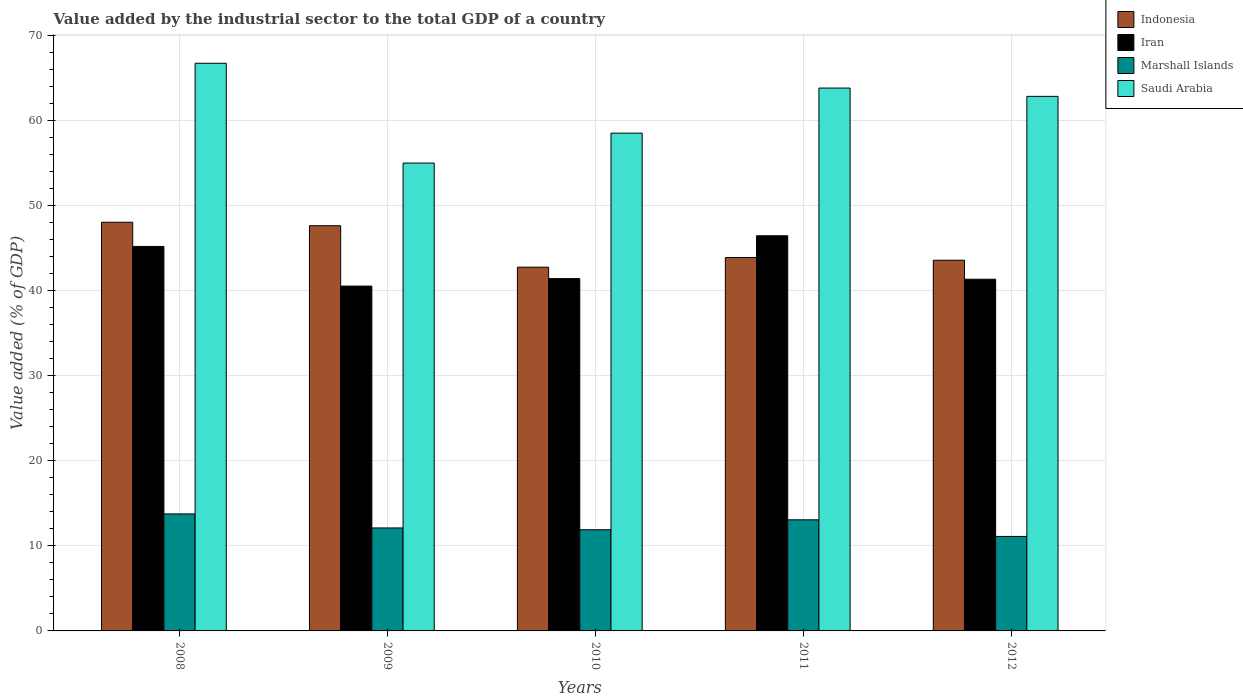How many different coloured bars are there?
Provide a succinct answer. 4. How many groups of bars are there?
Offer a terse response. 5. Are the number of bars per tick equal to the number of legend labels?
Provide a short and direct response. Yes. Are the number of bars on each tick of the X-axis equal?
Ensure brevity in your answer.  Yes. How many bars are there on the 3rd tick from the right?
Offer a terse response. 4. In how many cases, is the number of bars for a given year not equal to the number of legend labels?
Make the answer very short. 0. What is the value added by the industrial sector to the total GDP in Indonesia in 2010?
Keep it short and to the point. 42.78. Across all years, what is the maximum value added by the industrial sector to the total GDP in Indonesia?
Ensure brevity in your answer.  48.06. Across all years, what is the minimum value added by the industrial sector to the total GDP in Indonesia?
Ensure brevity in your answer.  42.78. In which year was the value added by the industrial sector to the total GDP in Iran maximum?
Provide a succinct answer. 2011. In which year was the value added by the industrial sector to the total GDP in Iran minimum?
Give a very brief answer. 2009. What is the total value added by the industrial sector to the total GDP in Marshall Islands in the graph?
Offer a very short reply. 61.95. What is the difference between the value added by the industrial sector to the total GDP in Iran in 2009 and that in 2011?
Give a very brief answer. -5.92. What is the difference between the value added by the industrial sector to the total GDP in Indonesia in 2009 and the value added by the industrial sector to the total GDP in Iran in 2012?
Give a very brief answer. 6.29. What is the average value added by the industrial sector to the total GDP in Iran per year?
Give a very brief answer. 43.01. In the year 2010, what is the difference between the value added by the industrial sector to the total GDP in Saudi Arabia and value added by the industrial sector to the total GDP in Marshall Islands?
Give a very brief answer. 46.64. In how many years, is the value added by the industrial sector to the total GDP in Indonesia greater than 48 %?
Offer a terse response. 1. What is the ratio of the value added by the industrial sector to the total GDP in Iran in 2008 to that in 2012?
Keep it short and to the point. 1.09. Is the difference between the value added by the industrial sector to the total GDP in Saudi Arabia in 2011 and 2012 greater than the difference between the value added by the industrial sector to the total GDP in Marshall Islands in 2011 and 2012?
Give a very brief answer. No. What is the difference between the highest and the second highest value added by the industrial sector to the total GDP in Saudi Arabia?
Give a very brief answer. 2.92. What is the difference between the highest and the lowest value added by the industrial sector to the total GDP in Saudi Arabia?
Your response must be concise. 11.74. Is it the case that in every year, the sum of the value added by the industrial sector to the total GDP in Saudi Arabia and value added by the industrial sector to the total GDP in Iran is greater than the sum of value added by the industrial sector to the total GDP in Indonesia and value added by the industrial sector to the total GDP in Marshall Islands?
Keep it short and to the point. Yes. What does the 2nd bar from the right in 2008 represents?
Offer a terse response. Marshall Islands. Is it the case that in every year, the sum of the value added by the industrial sector to the total GDP in Saudi Arabia and value added by the industrial sector to the total GDP in Indonesia is greater than the value added by the industrial sector to the total GDP in Marshall Islands?
Provide a succinct answer. Yes. How many bars are there?
Provide a short and direct response. 20. How many years are there in the graph?
Offer a very short reply. 5. Are the values on the major ticks of Y-axis written in scientific E-notation?
Make the answer very short. No. Does the graph contain grids?
Provide a short and direct response. Yes. How many legend labels are there?
Ensure brevity in your answer.  4. What is the title of the graph?
Make the answer very short. Value added by the industrial sector to the total GDP of a country. Does "Swaziland" appear as one of the legend labels in the graph?
Make the answer very short. No. What is the label or title of the X-axis?
Keep it short and to the point. Years. What is the label or title of the Y-axis?
Your answer should be very brief. Value added (% of GDP). What is the Value added (% of GDP) of Indonesia in 2008?
Your answer should be compact. 48.06. What is the Value added (% of GDP) of Iran in 2008?
Provide a succinct answer. 45.21. What is the Value added (% of GDP) in Marshall Islands in 2008?
Offer a very short reply. 13.76. What is the Value added (% of GDP) of Saudi Arabia in 2008?
Offer a very short reply. 66.76. What is the Value added (% of GDP) of Indonesia in 2009?
Make the answer very short. 47.65. What is the Value added (% of GDP) in Iran in 2009?
Ensure brevity in your answer.  40.55. What is the Value added (% of GDP) of Marshall Islands in 2009?
Your response must be concise. 12.11. What is the Value added (% of GDP) in Saudi Arabia in 2009?
Your answer should be compact. 55.02. What is the Value added (% of GDP) in Indonesia in 2010?
Offer a terse response. 42.78. What is the Value added (% of GDP) of Iran in 2010?
Give a very brief answer. 41.43. What is the Value added (% of GDP) in Marshall Islands in 2010?
Give a very brief answer. 11.9. What is the Value added (% of GDP) of Saudi Arabia in 2010?
Make the answer very short. 58.54. What is the Value added (% of GDP) of Indonesia in 2011?
Offer a very short reply. 43.91. What is the Value added (% of GDP) in Iran in 2011?
Offer a very short reply. 46.47. What is the Value added (% of GDP) in Marshall Islands in 2011?
Give a very brief answer. 13.07. What is the Value added (% of GDP) of Saudi Arabia in 2011?
Ensure brevity in your answer.  63.84. What is the Value added (% of GDP) in Indonesia in 2012?
Offer a terse response. 43.59. What is the Value added (% of GDP) in Iran in 2012?
Keep it short and to the point. 41.36. What is the Value added (% of GDP) in Marshall Islands in 2012?
Offer a very short reply. 11.11. What is the Value added (% of GDP) of Saudi Arabia in 2012?
Offer a terse response. 62.86. Across all years, what is the maximum Value added (% of GDP) in Indonesia?
Make the answer very short. 48.06. Across all years, what is the maximum Value added (% of GDP) of Iran?
Offer a very short reply. 46.47. Across all years, what is the maximum Value added (% of GDP) in Marshall Islands?
Provide a short and direct response. 13.76. Across all years, what is the maximum Value added (% of GDP) of Saudi Arabia?
Provide a succinct answer. 66.76. Across all years, what is the minimum Value added (% of GDP) in Indonesia?
Offer a very short reply. 42.78. Across all years, what is the minimum Value added (% of GDP) in Iran?
Provide a short and direct response. 40.55. Across all years, what is the minimum Value added (% of GDP) of Marshall Islands?
Your answer should be very brief. 11.11. Across all years, what is the minimum Value added (% of GDP) in Saudi Arabia?
Give a very brief answer. 55.02. What is the total Value added (% of GDP) in Indonesia in the graph?
Give a very brief answer. 226. What is the total Value added (% of GDP) in Iran in the graph?
Ensure brevity in your answer.  215.03. What is the total Value added (% of GDP) of Marshall Islands in the graph?
Give a very brief answer. 61.95. What is the total Value added (% of GDP) of Saudi Arabia in the graph?
Make the answer very short. 307.02. What is the difference between the Value added (% of GDP) of Indonesia in 2008 and that in 2009?
Give a very brief answer. 0.41. What is the difference between the Value added (% of GDP) of Iran in 2008 and that in 2009?
Offer a terse response. 4.66. What is the difference between the Value added (% of GDP) of Marshall Islands in 2008 and that in 2009?
Your response must be concise. 1.65. What is the difference between the Value added (% of GDP) of Saudi Arabia in 2008 and that in 2009?
Your answer should be very brief. 11.74. What is the difference between the Value added (% of GDP) in Indonesia in 2008 and that in 2010?
Ensure brevity in your answer.  5.28. What is the difference between the Value added (% of GDP) of Iran in 2008 and that in 2010?
Provide a short and direct response. 3.78. What is the difference between the Value added (% of GDP) in Marshall Islands in 2008 and that in 2010?
Offer a terse response. 1.86. What is the difference between the Value added (% of GDP) of Saudi Arabia in 2008 and that in 2010?
Your response must be concise. 8.22. What is the difference between the Value added (% of GDP) of Indonesia in 2008 and that in 2011?
Your answer should be very brief. 4.15. What is the difference between the Value added (% of GDP) in Iran in 2008 and that in 2011?
Offer a terse response. -1.26. What is the difference between the Value added (% of GDP) of Marshall Islands in 2008 and that in 2011?
Your response must be concise. 0.69. What is the difference between the Value added (% of GDP) of Saudi Arabia in 2008 and that in 2011?
Give a very brief answer. 2.92. What is the difference between the Value added (% of GDP) of Indonesia in 2008 and that in 2012?
Offer a very short reply. 4.47. What is the difference between the Value added (% of GDP) of Iran in 2008 and that in 2012?
Make the answer very short. 3.85. What is the difference between the Value added (% of GDP) in Marshall Islands in 2008 and that in 2012?
Your answer should be very brief. 2.65. What is the difference between the Value added (% of GDP) of Saudi Arabia in 2008 and that in 2012?
Ensure brevity in your answer.  3.89. What is the difference between the Value added (% of GDP) of Indonesia in 2009 and that in 2010?
Ensure brevity in your answer.  4.88. What is the difference between the Value added (% of GDP) of Iran in 2009 and that in 2010?
Give a very brief answer. -0.88. What is the difference between the Value added (% of GDP) of Marshall Islands in 2009 and that in 2010?
Provide a short and direct response. 0.21. What is the difference between the Value added (% of GDP) of Saudi Arabia in 2009 and that in 2010?
Provide a short and direct response. -3.52. What is the difference between the Value added (% of GDP) of Indonesia in 2009 and that in 2011?
Your answer should be very brief. 3.74. What is the difference between the Value added (% of GDP) in Iran in 2009 and that in 2011?
Ensure brevity in your answer.  -5.92. What is the difference between the Value added (% of GDP) in Marshall Islands in 2009 and that in 2011?
Offer a very short reply. -0.96. What is the difference between the Value added (% of GDP) in Saudi Arabia in 2009 and that in 2011?
Give a very brief answer. -8.82. What is the difference between the Value added (% of GDP) of Indonesia in 2009 and that in 2012?
Offer a terse response. 4.06. What is the difference between the Value added (% of GDP) in Iran in 2009 and that in 2012?
Offer a very short reply. -0.81. What is the difference between the Value added (% of GDP) in Saudi Arabia in 2009 and that in 2012?
Your response must be concise. -7.84. What is the difference between the Value added (% of GDP) in Indonesia in 2010 and that in 2011?
Keep it short and to the point. -1.14. What is the difference between the Value added (% of GDP) in Iran in 2010 and that in 2011?
Make the answer very short. -5.04. What is the difference between the Value added (% of GDP) in Marshall Islands in 2010 and that in 2011?
Provide a short and direct response. -1.17. What is the difference between the Value added (% of GDP) in Saudi Arabia in 2010 and that in 2011?
Provide a succinct answer. -5.3. What is the difference between the Value added (% of GDP) in Indonesia in 2010 and that in 2012?
Make the answer very short. -0.82. What is the difference between the Value added (% of GDP) in Iran in 2010 and that in 2012?
Give a very brief answer. 0.07. What is the difference between the Value added (% of GDP) of Marshall Islands in 2010 and that in 2012?
Make the answer very short. 0.79. What is the difference between the Value added (% of GDP) in Saudi Arabia in 2010 and that in 2012?
Your answer should be very brief. -4.32. What is the difference between the Value added (% of GDP) in Indonesia in 2011 and that in 2012?
Provide a short and direct response. 0.32. What is the difference between the Value added (% of GDP) in Iran in 2011 and that in 2012?
Give a very brief answer. 5.11. What is the difference between the Value added (% of GDP) of Marshall Islands in 2011 and that in 2012?
Give a very brief answer. 1.95. What is the difference between the Value added (% of GDP) of Saudi Arabia in 2011 and that in 2012?
Provide a short and direct response. 0.98. What is the difference between the Value added (% of GDP) in Indonesia in 2008 and the Value added (% of GDP) in Iran in 2009?
Keep it short and to the point. 7.51. What is the difference between the Value added (% of GDP) in Indonesia in 2008 and the Value added (% of GDP) in Marshall Islands in 2009?
Give a very brief answer. 35.95. What is the difference between the Value added (% of GDP) of Indonesia in 2008 and the Value added (% of GDP) of Saudi Arabia in 2009?
Offer a terse response. -6.96. What is the difference between the Value added (% of GDP) in Iran in 2008 and the Value added (% of GDP) in Marshall Islands in 2009?
Your answer should be very brief. 33.1. What is the difference between the Value added (% of GDP) of Iran in 2008 and the Value added (% of GDP) of Saudi Arabia in 2009?
Provide a succinct answer. -9.81. What is the difference between the Value added (% of GDP) in Marshall Islands in 2008 and the Value added (% of GDP) in Saudi Arabia in 2009?
Make the answer very short. -41.26. What is the difference between the Value added (% of GDP) in Indonesia in 2008 and the Value added (% of GDP) in Iran in 2010?
Make the answer very short. 6.63. What is the difference between the Value added (% of GDP) in Indonesia in 2008 and the Value added (% of GDP) in Marshall Islands in 2010?
Offer a very short reply. 36.16. What is the difference between the Value added (% of GDP) of Indonesia in 2008 and the Value added (% of GDP) of Saudi Arabia in 2010?
Ensure brevity in your answer.  -10.48. What is the difference between the Value added (% of GDP) of Iran in 2008 and the Value added (% of GDP) of Marshall Islands in 2010?
Keep it short and to the point. 33.32. What is the difference between the Value added (% of GDP) in Iran in 2008 and the Value added (% of GDP) in Saudi Arabia in 2010?
Provide a short and direct response. -13.32. What is the difference between the Value added (% of GDP) in Marshall Islands in 2008 and the Value added (% of GDP) in Saudi Arabia in 2010?
Give a very brief answer. -44.78. What is the difference between the Value added (% of GDP) of Indonesia in 2008 and the Value added (% of GDP) of Iran in 2011?
Your answer should be compact. 1.59. What is the difference between the Value added (% of GDP) in Indonesia in 2008 and the Value added (% of GDP) in Marshall Islands in 2011?
Keep it short and to the point. 34.99. What is the difference between the Value added (% of GDP) of Indonesia in 2008 and the Value added (% of GDP) of Saudi Arabia in 2011?
Give a very brief answer. -15.78. What is the difference between the Value added (% of GDP) in Iran in 2008 and the Value added (% of GDP) in Marshall Islands in 2011?
Give a very brief answer. 32.15. What is the difference between the Value added (% of GDP) of Iran in 2008 and the Value added (% of GDP) of Saudi Arabia in 2011?
Ensure brevity in your answer.  -18.63. What is the difference between the Value added (% of GDP) of Marshall Islands in 2008 and the Value added (% of GDP) of Saudi Arabia in 2011?
Make the answer very short. -50.08. What is the difference between the Value added (% of GDP) of Indonesia in 2008 and the Value added (% of GDP) of Iran in 2012?
Make the answer very short. 6.7. What is the difference between the Value added (% of GDP) in Indonesia in 2008 and the Value added (% of GDP) in Marshall Islands in 2012?
Provide a succinct answer. 36.95. What is the difference between the Value added (% of GDP) in Indonesia in 2008 and the Value added (% of GDP) in Saudi Arabia in 2012?
Ensure brevity in your answer.  -14.8. What is the difference between the Value added (% of GDP) in Iran in 2008 and the Value added (% of GDP) in Marshall Islands in 2012?
Offer a terse response. 34.1. What is the difference between the Value added (% of GDP) in Iran in 2008 and the Value added (% of GDP) in Saudi Arabia in 2012?
Offer a very short reply. -17.65. What is the difference between the Value added (% of GDP) of Marshall Islands in 2008 and the Value added (% of GDP) of Saudi Arabia in 2012?
Your answer should be compact. -49.1. What is the difference between the Value added (% of GDP) in Indonesia in 2009 and the Value added (% of GDP) in Iran in 2010?
Your response must be concise. 6.22. What is the difference between the Value added (% of GDP) of Indonesia in 2009 and the Value added (% of GDP) of Marshall Islands in 2010?
Offer a very short reply. 35.75. What is the difference between the Value added (% of GDP) in Indonesia in 2009 and the Value added (% of GDP) in Saudi Arabia in 2010?
Provide a short and direct response. -10.89. What is the difference between the Value added (% of GDP) of Iran in 2009 and the Value added (% of GDP) of Marshall Islands in 2010?
Keep it short and to the point. 28.65. What is the difference between the Value added (% of GDP) of Iran in 2009 and the Value added (% of GDP) of Saudi Arabia in 2010?
Keep it short and to the point. -17.99. What is the difference between the Value added (% of GDP) in Marshall Islands in 2009 and the Value added (% of GDP) in Saudi Arabia in 2010?
Ensure brevity in your answer.  -46.43. What is the difference between the Value added (% of GDP) in Indonesia in 2009 and the Value added (% of GDP) in Iran in 2011?
Provide a short and direct response. 1.18. What is the difference between the Value added (% of GDP) of Indonesia in 2009 and the Value added (% of GDP) of Marshall Islands in 2011?
Offer a terse response. 34.59. What is the difference between the Value added (% of GDP) in Indonesia in 2009 and the Value added (% of GDP) in Saudi Arabia in 2011?
Make the answer very short. -16.19. What is the difference between the Value added (% of GDP) in Iran in 2009 and the Value added (% of GDP) in Marshall Islands in 2011?
Offer a terse response. 27.49. What is the difference between the Value added (% of GDP) of Iran in 2009 and the Value added (% of GDP) of Saudi Arabia in 2011?
Keep it short and to the point. -23.29. What is the difference between the Value added (% of GDP) in Marshall Islands in 2009 and the Value added (% of GDP) in Saudi Arabia in 2011?
Give a very brief answer. -51.73. What is the difference between the Value added (% of GDP) in Indonesia in 2009 and the Value added (% of GDP) in Iran in 2012?
Ensure brevity in your answer.  6.29. What is the difference between the Value added (% of GDP) of Indonesia in 2009 and the Value added (% of GDP) of Marshall Islands in 2012?
Keep it short and to the point. 36.54. What is the difference between the Value added (% of GDP) of Indonesia in 2009 and the Value added (% of GDP) of Saudi Arabia in 2012?
Your response must be concise. -15.21. What is the difference between the Value added (% of GDP) of Iran in 2009 and the Value added (% of GDP) of Marshall Islands in 2012?
Your response must be concise. 29.44. What is the difference between the Value added (% of GDP) in Iran in 2009 and the Value added (% of GDP) in Saudi Arabia in 2012?
Offer a very short reply. -22.31. What is the difference between the Value added (% of GDP) in Marshall Islands in 2009 and the Value added (% of GDP) in Saudi Arabia in 2012?
Make the answer very short. -50.75. What is the difference between the Value added (% of GDP) of Indonesia in 2010 and the Value added (% of GDP) of Iran in 2011?
Provide a short and direct response. -3.7. What is the difference between the Value added (% of GDP) in Indonesia in 2010 and the Value added (% of GDP) in Marshall Islands in 2011?
Offer a terse response. 29.71. What is the difference between the Value added (% of GDP) of Indonesia in 2010 and the Value added (% of GDP) of Saudi Arabia in 2011?
Your answer should be compact. -21.07. What is the difference between the Value added (% of GDP) of Iran in 2010 and the Value added (% of GDP) of Marshall Islands in 2011?
Provide a short and direct response. 28.37. What is the difference between the Value added (% of GDP) in Iran in 2010 and the Value added (% of GDP) in Saudi Arabia in 2011?
Offer a terse response. -22.41. What is the difference between the Value added (% of GDP) in Marshall Islands in 2010 and the Value added (% of GDP) in Saudi Arabia in 2011?
Ensure brevity in your answer.  -51.94. What is the difference between the Value added (% of GDP) of Indonesia in 2010 and the Value added (% of GDP) of Iran in 2012?
Offer a very short reply. 1.42. What is the difference between the Value added (% of GDP) of Indonesia in 2010 and the Value added (% of GDP) of Marshall Islands in 2012?
Ensure brevity in your answer.  31.66. What is the difference between the Value added (% of GDP) of Indonesia in 2010 and the Value added (% of GDP) of Saudi Arabia in 2012?
Make the answer very short. -20.09. What is the difference between the Value added (% of GDP) of Iran in 2010 and the Value added (% of GDP) of Marshall Islands in 2012?
Make the answer very short. 30.32. What is the difference between the Value added (% of GDP) of Iran in 2010 and the Value added (% of GDP) of Saudi Arabia in 2012?
Your answer should be very brief. -21.43. What is the difference between the Value added (% of GDP) of Marshall Islands in 2010 and the Value added (% of GDP) of Saudi Arabia in 2012?
Keep it short and to the point. -50.97. What is the difference between the Value added (% of GDP) of Indonesia in 2011 and the Value added (% of GDP) of Iran in 2012?
Provide a short and direct response. 2.55. What is the difference between the Value added (% of GDP) in Indonesia in 2011 and the Value added (% of GDP) in Marshall Islands in 2012?
Your answer should be very brief. 32.8. What is the difference between the Value added (% of GDP) in Indonesia in 2011 and the Value added (% of GDP) in Saudi Arabia in 2012?
Make the answer very short. -18.95. What is the difference between the Value added (% of GDP) of Iran in 2011 and the Value added (% of GDP) of Marshall Islands in 2012?
Ensure brevity in your answer.  35.36. What is the difference between the Value added (% of GDP) of Iran in 2011 and the Value added (% of GDP) of Saudi Arabia in 2012?
Your answer should be very brief. -16.39. What is the difference between the Value added (% of GDP) of Marshall Islands in 2011 and the Value added (% of GDP) of Saudi Arabia in 2012?
Ensure brevity in your answer.  -49.8. What is the average Value added (% of GDP) in Indonesia per year?
Your response must be concise. 45.2. What is the average Value added (% of GDP) in Iran per year?
Keep it short and to the point. 43.01. What is the average Value added (% of GDP) of Marshall Islands per year?
Ensure brevity in your answer.  12.39. What is the average Value added (% of GDP) in Saudi Arabia per year?
Your response must be concise. 61.4. In the year 2008, what is the difference between the Value added (% of GDP) of Indonesia and Value added (% of GDP) of Iran?
Keep it short and to the point. 2.85. In the year 2008, what is the difference between the Value added (% of GDP) of Indonesia and Value added (% of GDP) of Marshall Islands?
Your answer should be compact. 34.3. In the year 2008, what is the difference between the Value added (% of GDP) in Indonesia and Value added (% of GDP) in Saudi Arabia?
Give a very brief answer. -18.7. In the year 2008, what is the difference between the Value added (% of GDP) in Iran and Value added (% of GDP) in Marshall Islands?
Your answer should be compact. 31.45. In the year 2008, what is the difference between the Value added (% of GDP) in Iran and Value added (% of GDP) in Saudi Arabia?
Offer a terse response. -21.54. In the year 2008, what is the difference between the Value added (% of GDP) in Marshall Islands and Value added (% of GDP) in Saudi Arabia?
Give a very brief answer. -53. In the year 2009, what is the difference between the Value added (% of GDP) of Indonesia and Value added (% of GDP) of Iran?
Ensure brevity in your answer.  7.1. In the year 2009, what is the difference between the Value added (% of GDP) of Indonesia and Value added (% of GDP) of Marshall Islands?
Offer a terse response. 35.54. In the year 2009, what is the difference between the Value added (% of GDP) of Indonesia and Value added (% of GDP) of Saudi Arabia?
Give a very brief answer. -7.37. In the year 2009, what is the difference between the Value added (% of GDP) in Iran and Value added (% of GDP) in Marshall Islands?
Ensure brevity in your answer.  28.44. In the year 2009, what is the difference between the Value added (% of GDP) in Iran and Value added (% of GDP) in Saudi Arabia?
Provide a short and direct response. -14.47. In the year 2009, what is the difference between the Value added (% of GDP) of Marshall Islands and Value added (% of GDP) of Saudi Arabia?
Keep it short and to the point. -42.91. In the year 2010, what is the difference between the Value added (% of GDP) in Indonesia and Value added (% of GDP) in Iran?
Offer a very short reply. 1.34. In the year 2010, what is the difference between the Value added (% of GDP) in Indonesia and Value added (% of GDP) in Marshall Islands?
Your answer should be very brief. 30.88. In the year 2010, what is the difference between the Value added (% of GDP) of Indonesia and Value added (% of GDP) of Saudi Arabia?
Offer a very short reply. -15.76. In the year 2010, what is the difference between the Value added (% of GDP) in Iran and Value added (% of GDP) in Marshall Islands?
Your answer should be compact. 29.53. In the year 2010, what is the difference between the Value added (% of GDP) in Iran and Value added (% of GDP) in Saudi Arabia?
Make the answer very short. -17.11. In the year 2010, what is the difference between the Value added (% of GDP) in Marshall Islands and Value added (% of GDP) in Saudi Arabia?
Give a very brief answer. -46.64. In the year 2011, what is the difference between the Value added (% of GDP) of Indonesia and Value added (% of GDP) of Iran?
Provide a succinct answer. -2.56. In the year 2011, what is the difference between the Value added (% of GDP) of Indonesia and Value added (% of GDP) of Marshall Islands?
Provide a short and direct response. 30.85. In the year 2011, what is the difference between the Value added (% of GDP) in Indonesia and Value added (% of GDP) in Saudi Arabia?
Offer a very short reply. -19.93. In the year 2011, what is the difference between the Value added (% of GDP) in Iran and Value added (% of GDP) in Marshall Islands?
Your answer should be compact. 33.41. In the year 2011, what is the difference between the Value added (% of GDP) of Iran and Value added (% of GDP) of Saudi Arabia?
Make the answer very short. -17.37. In the year 2011, what is the difference between the Value added (% of GDP) of Marshall Islands and Value added (% of GDP) of Saudi Arabia?
Keep it short and to the point. -50.78. In the year 2012, what is the difference between the Value added (% of GDP) of Indonesia and Value added (% of GDP) of Iran?
Provide a short and direct response. 2.23. In the year 2012, what is the difference between the Value added (% of GDP) of Indonesia and Value added (% of GDP) of Marshall Islands?
Keep it short and to the point. 32.48. In the year 2012, what is the difference between the Value added (% of GDP) of Indonesia and Value added (% of GDP) of Saudi Arabia?
Your answer should be compact. -19.27. In the year 2012, what is the difference between the Value added (% of GDP) of Iran and Value added (% of GDP) of Marshall Islands?
Offer a very short reply. 30.25. In the year 2012, what is the difference between the Value added (% of GDP) in Iran and Value added (% of GDP) in Saudi Arabia?
Offer a very short reply. -21.5. In the year 2012, what is the difference between the Value added (% of GDP) in Marshall Islands and Value added (% of GDP) in Saudi Arabia?
Your response must be concise. -51.75. What is the ratio of the Value added (% of GDP) in Indonesia in 2008 to that in 2009?
Give a very brief answer. 1.01. What is the ratio of the Value added (% of GDP) of Iran in 2008 to that in 2009?
Offer a terse response. 1.11. What is the ratio of the Value added (% of GDP) of Marshall Islands in 2008 to that in 2009?
Offer a terse response. 1.14. What is the ratio of the Value added (% of GDP) of Saudi Arabia in 2008 to that in 2009?
Give a very brief answer. 1.21. What is the ratio of the Value added (% of GDP) in Indonesia in 2008 to that in 2010?
Your answer should be compact. 1.12. What is the ratio of the Value added (% of GDP) of Iran in 2008 to that in 2010?
Ensure brevity in your answer.  1.09. What is the ratio of the Value added (% of GDP) of Marshall Islands in 2008 to that in 2010?
Offer a very short reply. 1.16. What is the ratio of the Value added (% of GDP) in Saudi Arabia in 2008 to that in 2010?
Provide a short and direct response. 1.14. What is the ratio of the Value added (% of GDP) of Indonesia in 2008 to that in 2011?
Provide a short and direct response. 1.09. What is the ratio of the Value added (% of GDP) in Iran in 2008 to that in 2011?
Make the answer very short. 0.97. What is the ratio of the Value added (% of GDP) in Marshall Islands in 2008 to that in 2011?
Keep it short and to the point. 1.05. What is the ratio of the Value added (% of GDP) in Saudi Arabia in 2008 to that in 2011?
Make the answer very short. 1.05. What is the ratio of the Value added (% of GDP) of Indonesia in 2008 to that in 2012?
Provide a short and direct response. 1.1. What is the ratio of the Value added (% of GDP) of Iran in 2008 to that in 2012?
Keep it short and to the point. 1.09. What is the ratio of the Value added (% of GDP) in Marshall Islands in 2008 to that in 2012?
Keep it short and to the point. 1.24. What is the ratio of the Value added (% of GDP) in Saudi Arabia in 2008 to that in 2012?
Your response must be concise. 1.06. What is the ratio of the Value added (% of GDP) of Indonesia in 2009 to that in 2010?
Give a very brief answer. 1.11. What is the ratio of the Value added (% of GDP) of Iran in 2009 to that in 2010?
Offer a very short reply. 0.98. What is the ratio of the Value added (% of GDP) of Marshall Islands in 2009 to that in 2010?
Give a very brief answer. 1.02. What is the ratio of the Value added (% of GDP) in Saudi Arabia in 2009 to that in 2010?
Offer a very short reply. 0.94. What is the ratio of the Value added (% of GDP) of Indonesia in 2009 to that in 2011?
Provide a short and direct response. 1.09. What is the ratio of the Value added (% of GDP) in Iran in 2009 to that in 2011?
Your answer should be compact. 0.87. What is the ratio of the Value added (% of GDP) of Marshall Islands in 2009 to that in 2011?
Your response must be concise. 0.93. What is the ratio of the Value added (% of GDP) of Saudi Arabia in 2009 to that in 2011?
Offer a very short reply. 0.86. What is the ratio of the Value added (% of GDP) in Indonesia in 2009 to that in 2012?
Offer a very short reply. 1.09. What is the ratio of the Value added (% of GDP) of Iran in 2009 to that in 2012?
Give a very brief answer. 0.98. What is the ratio of the Value added (% of GDP) in Marshall Islands in 2009 to that in 2012?
Make the answer very short. 1.09. What is the ratio of the Value added (% of GDP) in Saudi Arabia in 2009 to that in 2012?
Make the answer very short. 0.88. What is the ratio of the Value added (% of GDP) in Indonesia in 2010 to that in 2011?
Offer a terse response. 0.97. What is the ratio of the Value added (% of GDP) in Iran in 2010 to that in 2011?
Your response must be concise. 0.89. What is the ratio of the Value added (% of GDP) of Marshall Islands in 2010 to that in 2011?
Your answer should be compact. 0.91. What is the ratio of the Value added (% of GDP) in Saudi Arabia in 2010 to that in 2011?
Offer a terse response. 0.92. What is the ratio of the Value added (% of GDP) in Indonesia in 2010 to that in 2012?
Keep it short and to the point. 0.98. What is the ratio of the Value added (% of GDP) of Iran in 2010 to that in 2012?
Give a very brief answer. 1. What is the ratio of the Value added (% of GDP) in Marshall Islands in 2010 to that in 2012?
Keep it short and to the point. 1.07. What is the ratio of the Value added (% of GDP) in Saudi Arabia in 2010 to that in 2012?
Your answer should be very brief. 0.93. What is the ratio of the Value added (% of GDP) of Indonesia in 2011 to that in 2012?
Your response must be concise. 1.01. What is the ratio of the Value added (% of GDP) of Iran in 2011 to that in 2012?
Your answer should be very brief. 1.12. What is the ratio of the Value added (% of GDP) in Marshall Islands in 2011 to that in 2012?
Keep it short and to the point. 1.18. What is the ratio of the Value added (% of GDP) in Saudi Arabia in 2011 to that in 2012?
Offer a very short reply. 1.02. What is the difference between the highest and the second highest Value added (% of GDP) of Indonesia?
Your answer should be compact. 0.41. What is the difference between the highest and the second highest Value added (% of GDP) in Iran?
Your answer should be compact. 1.26. What is the difference between the highest and the second highest Value added (% of GDP) in Marshall Islands?
Make the answer very short. 0.69. What is the difference between the highest and the second highest Value added (% of GDP) in Saudi Arabia?
Offer a very short reply. 2.92. What is the difference between the highest and the lowest Value added (% of GDP) in Indonesia?
Provide a short and direct response. 5.28. What is the difference between the highest and the lowest Value added (% of GDP) in Iran?
Keep it short and to the point. 5.92. What is the difference between the highest and the lowest Value added (% of GDP) of Marshall Islands?
Make the answer very short. 2.65. What is the difference between the highest and the lowest Value added (% of GDP) in Saudi Arabia?
Your response must be concise. 11.74. 